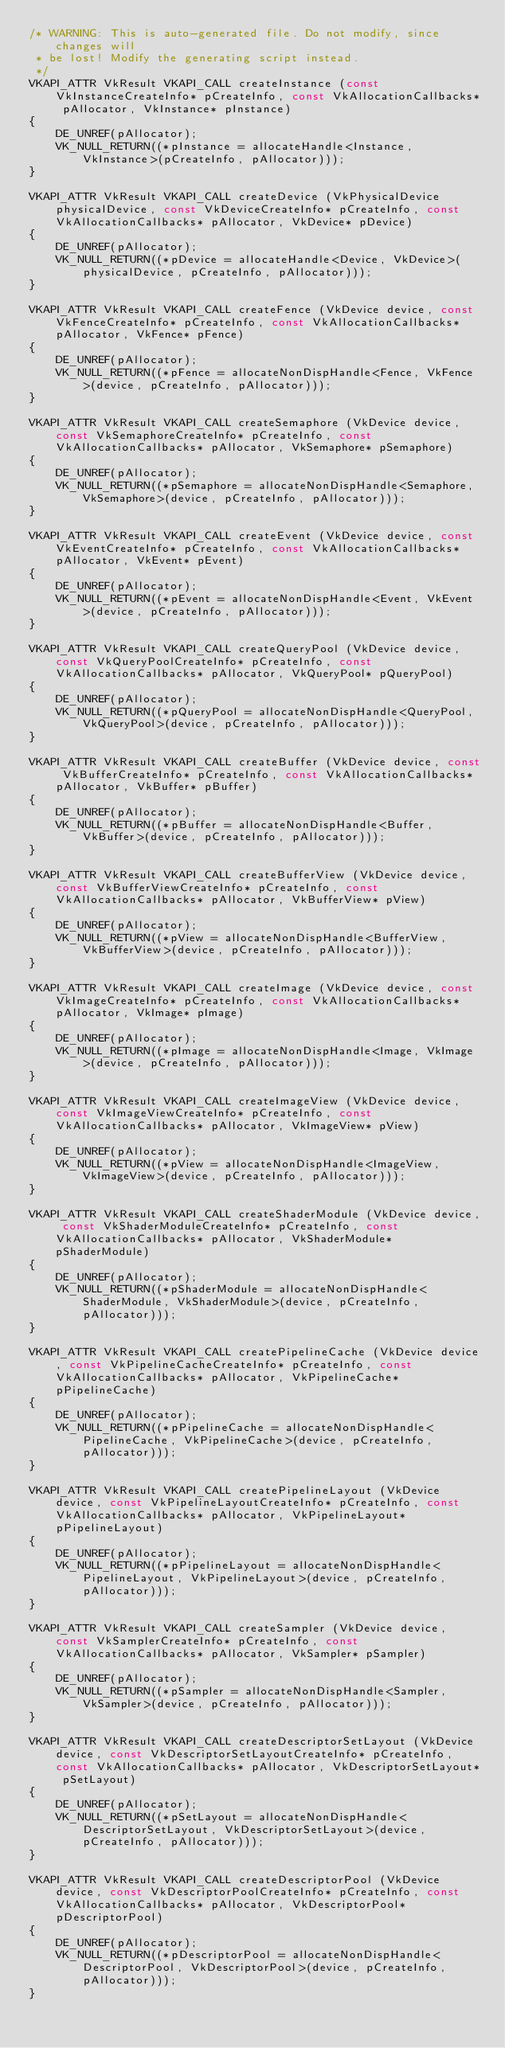<code> <loc_0><loc_0><loc_500><loc_500><_C++_>/* WARNING: This is auto-generated file. Do not modify, since changes will
 * be lost! Modify the generating script instead.
 */
VKAPI_ATTR VkResult VKAPI_CALL createInstance (const VkInstanceCreateInfo* pCreateInfo, const VkAllocationCallbacks* pAllocator, VkInstance* pInstance)
{
	DE_UNREF(pAllocator);
	VK_NULL_RETURN((*pInstance = allocateHandle<Instance, VkInstance>(pCreateInfo, pAllocator)));
}

VKAPI_ATTR VkResult VKAPI_CALL createDevice (VkPhysicalDevice physicalDevice, const VkDeviceCreateInfo* pCreateInfo, const VkAllocationCallbacks* pAllocator, VkDevice* pDevice)
{
	DE_UNREF(pAllocator);
	VK_NULL_RETURN((*pDevice = allocateHandle<Device, VkDevice>(physicalDevice, pCreateInfo, pAllocator)));
}

VKAPI_ATTR VkResult VKAPI_CALL createFence (VkDevice device, const VkFenceCreateInfo* pCreateInfo, const VkAllocationCallbacks* pAllocator, VkFence* pFence)
{
	DE_UNREF(pAllocator);
	VK_NULL_RETURN((*pFence = allocateNonDispHandle<Fence, VkFence>(device, pCreateInfo, pAllocator)));
}

VKAPI_ATTR VkResult VKAPI_CALL createSemaphore (VkDevice device, const VkSemaphoreCreateInfo* pCreateInfo, const VkAllocationCallbacks* pAllocator, VkSemaphore* pSemaphore)
{
	DE_UNREF(pAllocator);
	VK_NULL_RETURN((*pSemaphore = allocateNonDispHandle<Semaphore, VkSemaphore>(device, pCreateInfo, pAllocator)));
}

VKAPI_ATTR VkResult VKAPI_CALL createEvent (VkDevice device, const VkEventCreateInfo* pCreateInfo, const VkAllocationCallbacks* pAllocator, VkEvent* pEvent)
{
	DE_UNREF(pAllocator);
	VK_NULL_RETURN((*pEvent = allocateNonDispHandle<Event, VkEvent>(device, pCreateInfo, pAllocator)));
}

VKAPI_ATTR VkResult VKAPI_CALL createQueryPool (VkDevice device, const VkQueryPoolCreateInfo* pCreateInfo, const VkAllocationCallbacks* pAllocator, VkQueryPool* pQueryPool)
{
	DE_UNREF(pAllocator);
	VK_NULL_RETURN((*pQueryPool = allocateNonDispHandle<QueryPool, VkQueryPool>(device, pCreateInfo, pAllocator)));
}

VKAPI_ATTR VkResult VKAPI_CALL createBuffer (VkDevice device, const VkBufferCreateInfo* pCreateInfo, const VkAllocationCallbacks* pAllocator, VkBuffer* pBuffer)
{
	DE_UNREF(pAllocator);
	VK_NULL_RETURN((*pBuffer = allocateNonDispHandle<Buffer, VkBuffer>(device, pCreateInfo, pAllocator)));
}

VKAPI_ATTR VkResult VKAPI_CALL createBufferView (VkDevice device, const VkBufferViewCreateInfo* pCreateInfo, const VkAllocationCallbacks* pAllocator, VkBufferView* pView)
{
	DE_UNREF(pAllocator);
	VK_NULL_RETURN((*pView = allocateNonDispHandle<BufferView, VkBufferView>(device, pCreateInfo, pAllocator)));
}

VKAPI_ATTR VkResult VKAPI_CALL createImage (VkDevice device, const VkImageCreateInfo* pCreateInfo, const VkAllocationCallbacks* pAllocator, VkImage* pImage)
{
	DE_UNREF(pAllocator);
	VK_NULL_RETURN((*pImage = allocateNonDispHandle<Image, VkImage>(device, pCreateInfo, pAllocator)));
}

VKAPI_ATTR VkResult VKAPI_CALL createImageView (VkDevice device, const VkImageViewCreateInfo* pCreateInfo, const VkAllocationCallbacks* pAllocator, VkImageView* pView)
{
	DE_UNREF(pAllocator);
	VK_NULL_RETURN((*pView = allocateNonDispHandle<ImageView, VkImageView>(device, pCreateInfo, pAllocator)));
}

VKAPI_ATTR VkResult VKAPI_CALL createShaderModule (VkDevice device, const VkShaderModuleCreateInfo* pCreateInfo, const VkAllocationCallbacks* pAllocator, VkShaderModule* pShaderModule)
{
	DE_UNREF(pAllocator);
	VK_NULL_RETURN((*pShaderModule = allocateNonDispHandle<ShaderModule, VkShaderModule>(device, pCreateInfo, pAllocator)));
}

VKAPI_ATTR VkResult VKAPI_CALL createPipelineCache (VkDevice device, const VkPipelineCacheCreateInfo* pCreateInfo, const VkAllocationCallbacks* pAllocator, VkPipelineCache* pPipelineCache)
{
	DE_UNREF(pAllocator);
	VK_NULL_RETURN((*pPipelineCache = allocateNonDispHandle<PipelineCache, VkPipelineCache>(device, pCreateInfo, pAllocator)));
}

VKAPI_ATTR VkResult VKAPI_CALL createPipelineLayout (VkDevice device, const VkPipelineLayoutCreateInfo* pCreateInfo, const VkAllocationCallbacks* pAllocator, VkPipelineLayout* pPipelineLayout)
{
	DE_UNREF(pAllocator);
	VK_NULL_RETURN((*pPipelineLayout = allocateNonDispHandle<PipelineLayout, VkPipelineLayout>(device, pCreateInfo, pAllocator)));
}

VKAPI_ATTR VkResult VKAPI_CALL createSampler (VkDevice device, const VkSamplerCreateInfo* pCreateInfo, const VkAllocationCallbacks* pAllocator, VkSampler* pSampler)
{
	DE_UNREF(pAllocator);
	VK_NULL_RETURN((*pSampler = allocateNonDispHandle<Sampler, VkSampler>(device, pCreateInfo, pAllocator)));
}

VKAPI_ATTR VkResult VKAPI_CALL createDescriptorSetLayout (VkDevice device, const VkDescriptorSetLayoutCreateInfo* pCreateInfo, const VkAllocationCallbacks* pAllocator, VkDescriptorSetLayout* pSetLayout)
{
	DE_UNREF(pAllocator);
	VK_NULL_RETURN((*pSetLayout = allocateNonDispHandle<DescriptorSetLayout, VkDescriptorSetLayout>(device, pCreateInfo, pAllocator)));
}

VKAPI_ATTR VkResult VKAPI_CALL createDescriptorPool (VkDevice device, const VkDescriptorPoolCreateInfo* pCreateInfo, const VkAllocationCallbacks* pAllocator, VkDescriptorPool* pDescriptorPool)
{
	DE_UNREF(pAllocator);
	VK_NULL_RETURN((*pDescriptorPool = allocateNonDispHandle<DescriptorPool, VkDescriptorPool>(device, pCreateInfo, pAllocator)));
}
</code> 